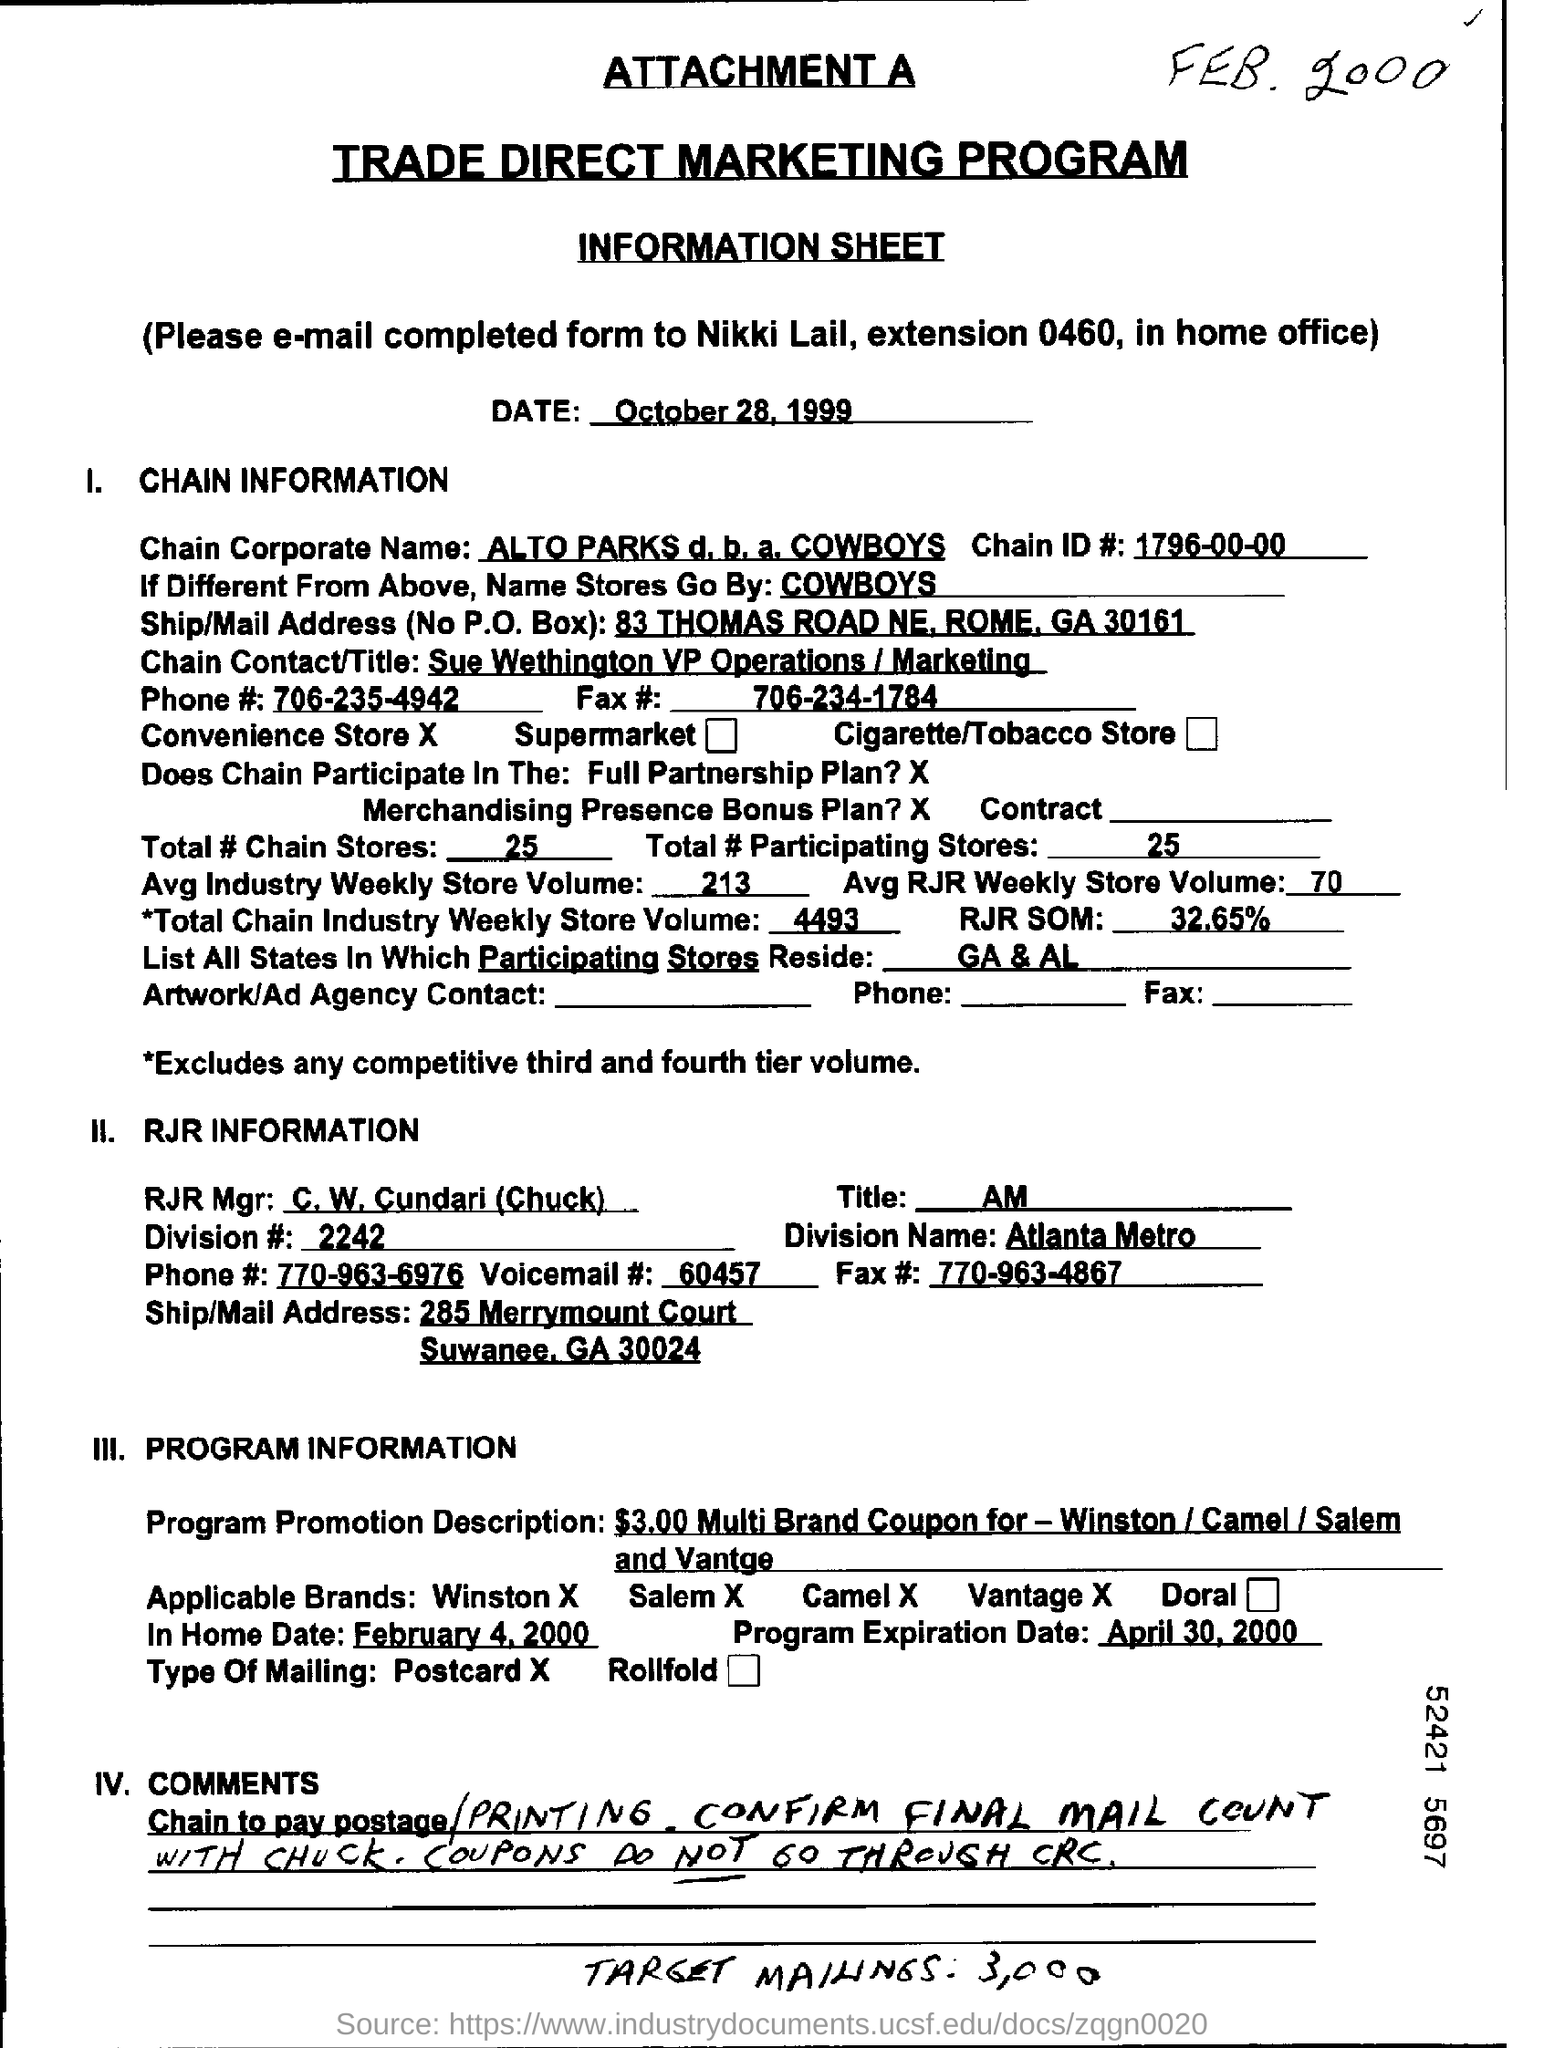Outline some significant characteristics in this image. The phone number for Chain is 706-235-4942. There are 25 chain stores in total. The Chain ID is 1796-00-00. The fax number for Chain is 706-234-1784. In total, there are 25 participating stores. 